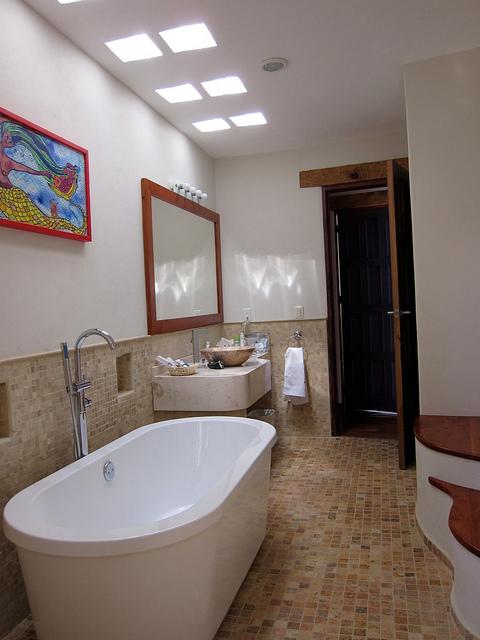Is the door opened or closed?
Be succinct. Open. What room is this?
Write a very short answer. Bathroom. What color is the tub?
Answer briefly. White. 